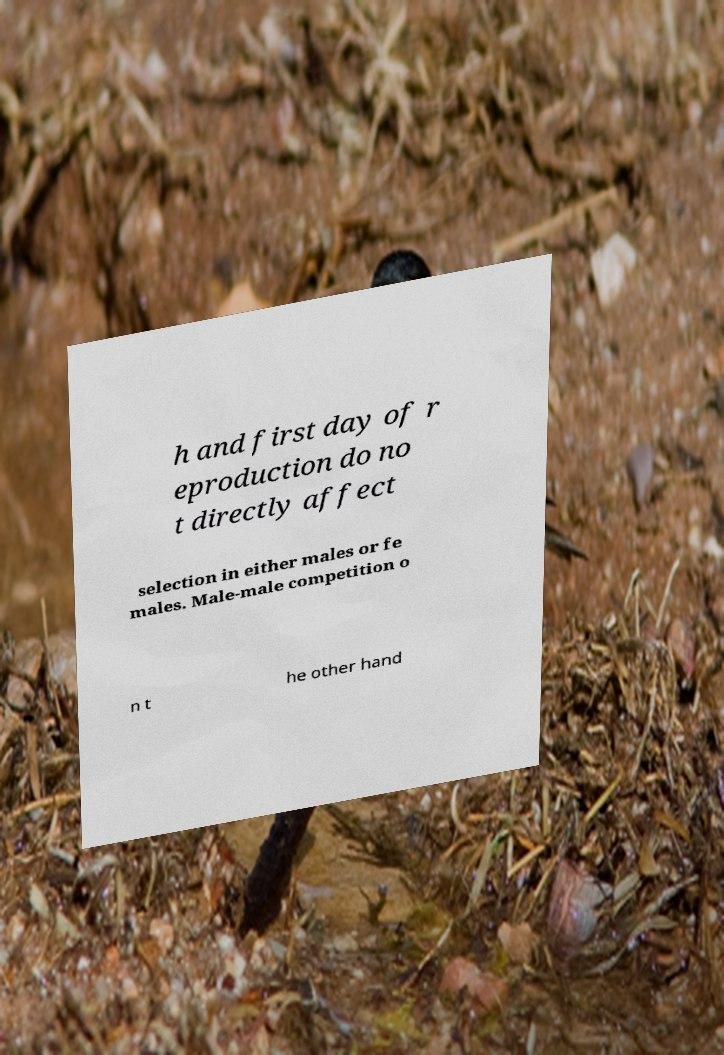Could you assist in decoding the text presented in this image and type it out clearly? h and first day of r eproduction do no t directly affect selection in either males or fe males. Male-male competition o n t he other hand 